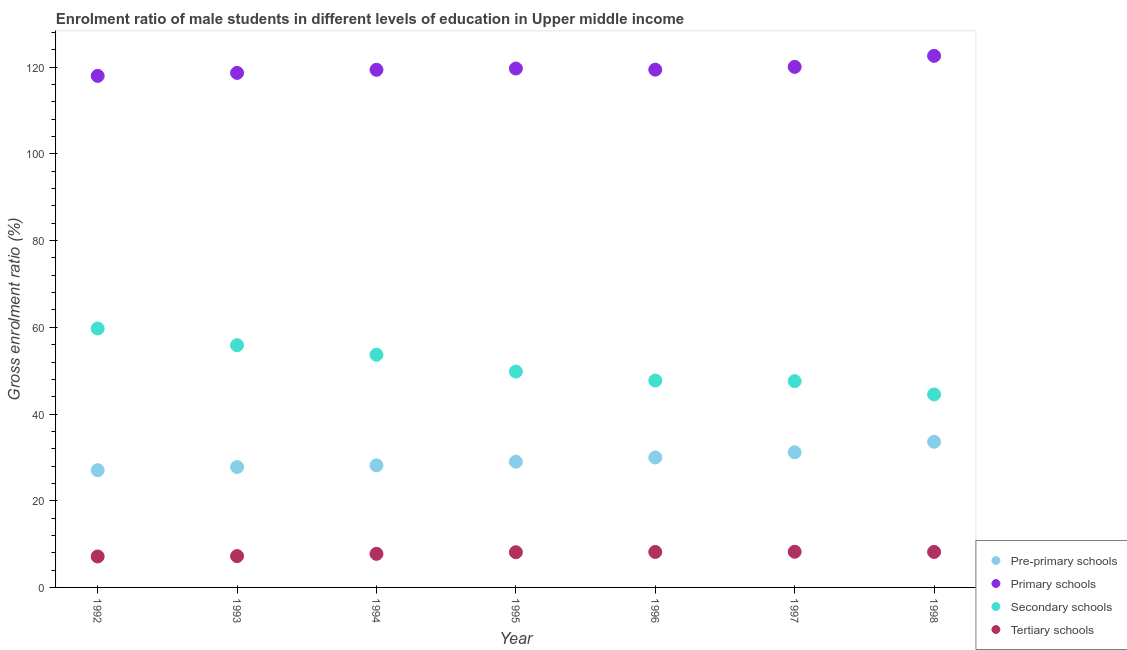How many different coloured dotlines are there?
Provide a short and direct response. 4. Is the number of dotlines equal to the number of legend labels?
Your answer should be compact. Yes. What is the gross enrolment ratio(female) in tertiary schools in 1994?
Provide a succinct answer. 7.74. Across all years, what is the maximum gross enrolment ratio(female) in pre-primary schools?
Provide a succinct answer. 33.59. Across all years, what is the minimum gross enrolment ratio(female) in secondary schools?
Provide a short and direct response. 44.52. In which year was the gross enrolment ratio(female) in primary schools maximum?
Your response must be concise. 1998. In which year was the gross enrolment ratio(female) in secondary schools minimum?
Make the answer very short. 1998. What is the total gross enrolment ratio(female) in secondary schools in the graph?
Give a very brief answer. 358.91. What is the difference between the gross enrolment ratio(female) in pre-primary schools in 1993 and that in 1996?
Make the answer very short. -2.2. What is the difference between the gross enrolment ratio(female) in secondary schools in 1996 and the gross enrolment ratio(female) in primary schools in 1995?
Provide a short and direct response. -71.98. What is the average gross enrolment ratio(female) in pre-primary schools per year?
Offer a terse response. 29.53. In the year 1996, what is the difference between the gross enrolment ratio(female) in pre-primary schools and gross enrolment ratio(female) in primary schools?
Keep it short and to the point. -89.47. What is the ratio of the gross enrolment ratio(female) in pre-primary schools in 1994 to that in 1997?
Ensure brevity in your answer.  0.9. Is the difference between the gross enrolment ratio(female) in primary schools in 1992 and 1994 greater than the difference between the gross enrolment ratio(female) in pre-primary schools in 1992 and 1994?
Your answer should be very brief. No. What is the difference between the highest and the second highest gross enrolment ratio(female) in primary schools?
Provide a short and direct response. 2.54. What is the difference between the highest and the lowest gross enrolment ratio(female) in primary schools?
Provide a succinct answer. 4.62. Is the sum of the gross enrolment ratio(female) in tertiary schools in 1992 and 1994 greater than the maximum gross enrolment ratio(female) in primary schools across all years?
Ensure brevity in your answer.  No. Is it the case that in every year, the sum of the gross enrolment ratio(female) in primary schools and gross enrolment ratio(female) in tertiary schools is greater than the sum of gross enrolment ratio(female) in pre-primary schools and gross enrolment ratio(female) in secondary schools?
Offer a very short reply. Yes. Is the gross enrolment ratio(female) in tertiary schools strictly less than the gross enrolment ratio(female) in secondary schools over the years?
Your answer should be compact. Yes. How many dotlines are there?
Offer a terse response. 4. How many years are there in the graph?
Your response must be concise. 7. What is the difference between two consecutive major ticks on the Y-axis?
Provide a succinct answer. 20. Are the values on the major ticks of Y-axis written in scientific E-notation?
Provide a succinct answer. No. What is the title of the graph?
Give a very brief answer. Enrolment ratio of male students in different levels of education in Upper middle income. Does "Management rating" appear as one of the legend labels in the graph?
Provide a succinct answer. No. What is the Gross enrolment ratio (%) of Pre-primary schools in 1992?
Provide a short and direct response. 27.05. What is the Gross enrolment ratio (%) of Primary schools in 1992?
Ensure brevity in your answer.  118.01. What is the Gross enrolment ratio (%) in Secondary schools in 1992?
Offer a very short reply. 59.73. What is the Gross enrolment ratio (%) in Tertiary schools in 1992?
Give a very brief answer. 7.14. What is the Gross enrolment ratio (%) of Pre-primary schools in 1993?
Your answer should be very brief. 27.77. What is the Gross enrolment ratio (%) of Primary schools in 1993?
Your response must be concise. 118.7. What is the Gross enrolment ratio (%) in Secondary schools in 1993?
Provide a short and direct response. 55.88. What is the Gross enrolment ratio (%) in Tertiary schools in 1993?
Provide a succinct answer. 7.23. What is the Gross enrolment ratio (%) in Pre-primary schools in 1994?
Make the answer very short. 28.16. What is the Gross enrolment ratio (%) of Primary schools in 1994?
Ensure brevity in your answer.  119.41. What is the Gross enrolment ratio (%) in Secondary schools in 1994?
Ensure brevity in your answer.  53.68. What is the Gross enrolment ratio (%) in Tertiary schools in 1994?
Your answer should be very brief. 7.74. What is the Gross enrolment ratio (%) in Pre-primary schools in 1995?
Ensure brevity in your answer.  29. What is the Gross enrolment ratio (%) of Primary schools in 1995?
Keep it short and to the point. 119.7. What is the Gross enrolment ratio (%) in Secondary schools in 1995?
Your answer should be compact. 49.79. What is the Gross enrolment ratio (%) in Tertiary schools in 1995?
Keep it short and to the point. 8.12. What is the Gross enrolment ratio (%) of Pre-primary schools in 1996?
Your response must be concise. 29.97. What is the Gross enrolment ratio (%) in Primary schools in 1996?
Provide a short and direct response. 119.44. What is the Gross enrolment ratio (%) in Secondary schools in 1996?
Your answer should be very brief. 47.72. What is the Gross enrolment ratio (%) in Tertiary schools in 1996?
Make the answer very short. 8.19. What is the Gross enrolment ratio (%) of Pre-primary schools in 1997?
Provide a succinct answer. 31.18. What is the Gross enrolment ratio (%) in Primary schools in 1997?
Make the answer very short. 120.08. What is the Gross enrolment ratio (%) in Secondary schools in 1997?
Offer a terse response. 47.59. What is the Gross enrolment ratio (%) in Tertiary schools in 1997?
Ensure brevity in your answer.  8.23. What is the Gross enrolment ratio (%) of Pre-primary schools in 1998?
Provide a succinct answer. 33.59. What is the Gross enrolment ratio (%) in Primary schools in 1998?
Your answer should be very brief. 122.63. What is the Gross enrolment ratio (%) of Secondary schools in 1998?
Your answer should be compact. 44.52. What is the Gross enrolment ratio (%) of Tertiary schools in 1998?
Your response must be concise. 8.19. Across all years, what is the maximum Gross enrolment ratio (%) of Pre-primary schools?
Provide a short and direct response. 33.59. Across all years, what is the maximum Gross enrolment ratio (%) in Primary schools?
Make the answer very short. 122.63. Across all years, what is the maximum Gross enrolment ratio (%) in Secondary schools?
Your answer should be compact. 59.73. Across all years, what is the maximum Gross enrolment ratio (%) of Tertiary schools?
Provide a short and direct response. 8.23. Across all years, what is the minimum Gross enrolment ratio (%) of Pre-primary schools?
Make the answer very short. 27.05. Across all years, what is the minimum Gross enrolment ratio (%) in Primary schools?
Your response must be concise. 118.01. Across all years, what is the minimum Gross enrolment ratio (%) of Secondary schools?
Give a very brief answer. 44.52. Across all years, what is the minimum Gross enrolment ratio (%) in Tertiary schools?
Your response must be concise. 7.14. What is the total Gross enrolment ratio (%) in Pre-primary schools in the graph?
Keep it short and to the point. 206.73. What is the total Gross enrolment ratio (%) of Primary schools in the graph?
Your answer should be very brief. 837.97. What is the total Gross enrolment ratio (%) in Secondary schools in the graph?
Your response must be concise. 358.91. What is the total Gross enrolment ratio (%) in Tertiary schools in the graph?
Your response must be concise. 54.83. What is the difference between the Gross enrolment ratio (%) of Pre-primary schools in 1992 and that in 1993?
Ensure brevity in your answer.  -0.72. What is the difference between the Gross enrolment ratio (%) in Primary schools in 1992 and that in 1993?
Make the answer very short. -0.69. What is the difference between the Gross enrolment ratio (%) of Secondary schools in 1992 and that in 1993?
Your answer should be compact. 3.86. What is the difference between the Gross enrolment ratio (%) of Tertiary schools in 1992 and that in 1993?
Offer a very short reply. -0.09. What is the difference between the Gross enrolment ratio (%) in Pre-primary schools in 1992 and that in 1994?
Provide a succinct answer. -1.11. What is the difference between the Gross enrolment ratio (%) in Primary schools in 1992 and that in 1994?
Keep it short and to the point. -1.4. What is the difference between the Gross enrolment ratio (%) in Secondary schools in 1992 and that in 1994?
Provide a short and direct response. 6.06. What is the difference between the Gross enrolment ratio (%) in Tertiary schools in 1992 and that in 1994?
Provide a succinct answer. -0.6. What is the difference between the Gross enrolment ratio (%) of Pre-primary schools in 1992 and that in 1995?
Your answer should be compact. -1.95. What is the difference between the Gross enrolment ratio (%) of Primary schools in 1992 and that in 1995?
Make the answer very short. -1.7. What is the difference between the Gross enrolment ratio (%) in Secondary schools in 1992 and that in 1995?
Give a very brief answer. 9.94. What is the difference between the Gross enrolment ratio (%) in Tertiary schools in 1992 and that in 1995?
Provide a short and direct response. -0.98. What is the difference between the Gross enrolment ratio (%) in Pre-primary schools in 1992 and that in 1996?
Offer a terse response. -2.92. What is the difference between the Gross enrolment ratio (%) in Primary schools in 1992 and that in 1996?
Keep it short and to the point. -1.44. What is the difference between the Gross enrolment ratio (%) in Secondary schools in 1992 and that in 1996?
Ensure brevity in your answer.  12.01. What is the difference between the Gross enrolment ratio (%) in Tertiary schools in 1992 and that in 1996?
Your response must be concise. -1.04. What is the difference between the Gross enrolment ratio (%) of Pre-primary schools in 1992 and that in 1997?
Your response must be concise. -4.13. What is the difference between the Gross enrolment ratio (%) of Primary schools in 1992 and that in 1997?
Keep it short and to the point. -2.08. What is the difference between the Gross enrolment ratio (%) of Secondary schools in 1992 and that in 1997?
Ensure brevity in your answer.  12.15. What is the difference between the Gross enrolment ratio (%) in Tertiary schools in 1992 and that in 1997?
Make the answer very short. -1.09. What is the difference between the Gross enrolment ratio (%) of Pre-primary schools in 1992 and that in 1998?
Your response must be concise. -6.54. What is the difference between the Gross enrolment ratio (%) of Primary schools in 1992 and that in 1998?
Ensure brevity in your answer.  -4.62. What is the difference between the Gross enrolment ratio (%) of Secondary schools in 1992 and that in 1998?
Offer a very short reply. 15.21. What is the difference between the Gross enrolment ratio (%) in Tertiary schools in 1992 and that in 1998?
Your answer should be very brief. -1.05. What is the difference between the Gross enrolment ratio (%) of Pre-primary schools in 1993 and that in 1994?
Your answer should be very brief. -0.39. What is the difference between the Gross enrolment ratio (%) in Primary schools in 1993 and that in 1994?
Keep it short and to the point. -0.71. What is the difference between the Gross enrolment ratio (%) in Secondary schools in 1993 and that in 1994?
Provide a short and direct response. 2.2. What is the difference between the Gross enrolment ratio (%) in Tertiary schools in 1993 and that in 1994?
Provide a short and direct response. -0.52. What is the difference between the Gross enrolment ratio (%) in Pre-primary schools in 1993 and that in 1995?
Offer a very short reply. -1.23. What is the difference between the Gross enrolment ratio (%) in Primary schools in 1993 and that in 1995?
Provide a short and direct response. -1.01. What is the difference between the Gross enrolment ratio (%) of Secondary schools in 1993 and that in 1995?
Offer a very short reply. 6.08. What is the difference between the Gross enrolment ratio (%) of Tertiary schools in 1993 and that in 1995?
Keep it short and to the point. -0.89. What is the difference between the Gross enrolment ratio (%) of Pre-primary schools in 1993 and that in 1996?
Offer a very short reply. -2.2. What is the difference between the Gross enrolment ratio (%) in Primary schools in 1993 and that in 1996?
Make the answer very short. -0.75. What is the difference between the Gross enrolment ratio (%) of Secondary schools in 1993 and that in 1996?
Offer a very short reply. 8.16. What is the difference between the Gross enrolment ratio (%) of Tertiary schools in 1993 and that in 1996?
Offer a terse response. -0.96. What is the difference between the Gross enrolment ratio (%) of Pre-primary schools in 1993 and that in 1997?
Give a very brief answer. -3.41. What is the difference between the Gross enrolment ratio (%) of Primary schools in 1993 and that in 1997?
Your answer should be very brief. -1.39. What is the difference between the Gross enrolment ratio (%) in Secondary schools in 1993 and that in 1997?
Give a very brief answer. 8.29. What is the difference between the Gross enrolment ratio (%) in Tertiary schools in 1993 and that in 1997?
Your answer should be very brief. -1. What is the difference between the Gross enrolment ratio (%) of Pre-primary schools in 1993 and that in 1998?
Provide a succinct answer. -5.82. What is the difference between the Gross enrolment ratio (%) of Primary schools in 1993 and that in 1998?
Provide a short and direct response. -3.93. What is the difference between the Gross enrolment ratio (%) of Secondary schools in 1993 and that in 1998?
Your answer should be very brief. 11.36. What is the difference between the Gross enrolment ratio (%) of Tertiary schools in 1993 and that in 1998?
Your response must be concise. -0.96. What is the difference between the Gross enrolment ratio (%) in Pre-primary schools in 1994 and that in 1995?
Give a very brief answer. -0.83. What is the difference between the Gross enrolment ratio (%) of Primary schools in 1994 and that in 1995?
Give a very brief answer. -0.29. What is the difference between the Gross enrolment ratio (%) in Secondary schools in 1994 and that in 1995?
Your response must be concise. 3.88. What is the difference between the Gross enrolment ratio (%) of Tertiary schools in 1994 and that in 1995?
Offer a very short reply. -0.37. What is the difference between the Gross enrolment ratio (%) of Pre-primary schools in 1994 and that in 1996?
Your answer should be compact. -1.81. What is the difference between the Gross enrolment ratio (%) in Primary schools in 1994 and that in 1996?
Offer a very short reply. -0.03. What is the difference between the Gross enrolment ratio (%) in Secondary schools in 1994 and that in 1996?
Ensure brevity in your answer.  5.95. What is the difference between the Gross enrolment ratio (%) of Tertiary schools in 1994 and that in 1996?
Your answer should be very brief. -0.44. What is the difference between the Gross enrolment ratio (%) in Pre-primary schools in 1994 and that in 1997?
Offer a very short reply. -3.02. What is the difference between the Gross enrolment ratio (%) of Primary schools in 1994 and that in 1997?
Your response must be concise. -0.68. What is the difference between the Gross enrolment ratio (%) in Secondary schools in 1994 and that in 1997?
Ensure brevity in your answer.  6.09. What is the difference between the Gross enrolment ratio (%) of Tertiary schools in 1994 and that in 1997?
Make the answer very short. -0.48. What is the difference between the Gross enrolment ratio (%) in Pre-primary schools in 1994 and that in 1998?
Offer a very short reply. -5.43. What is the difference between the Gross enrolment ratio (%) in Primary schools in 1994 and that in 1998?
Your answer should be very brief. -3.22. What is the difference between the Gross enrolment ratio (%) of Secondary schools in 1994 and that in 1998?
Offer a terse response. 9.15. What is the difference between the Gross enrolment ratio (%) in Tertiary schools in 1994 and that in 1998?
Keep it short and to the point. -0.45. What is the difference between the Gross enrolment ratio (%) of Pre-primary schools in 1995 and that in 1996?
Provide a succinct answer. -0.98. What is the difference between the Gross enrolment ratio (%) of Primary schools in 1995 and that in 1996?
Keep it short and to the point. 0.26. What is the difference between the Gross enrolment ratio (%) of Secondary schools in 1995 and that in 1996?
Ensure brevity in your answer.  2.07. What is the difference between the Gross enrolment ratio (%) of Tertiary schools in 1995 and that in 1996?
Your response must be concise. -0.07. What is the difference between the Gross enrolment ratio (%) in Pre-primary schools in 1995 and that in 1997?
Provide a succinct answer. -2.18. What is the difference between the Gross enrolment ratio (%) in Primary schools in 1995 and that in 1997?
Give a very brief answer. -0.38. What is the difference between the Gross enrolment ratio (%) in Secondary schools in 1995 and that in 1997?
Make the answer very short. 2.21. What is the difference between the Gross enrolment ratio (%) in Tertiary schools in 1995 and that in 1997?
Your response must be concise. -0.11. What is the difference between the Gross enrolment ratio (%) of Pre-primary schools in 1995 and that in 1998?
Ensure brevity in your answer.  -4.6. What is the difference between the Gross enrolment ratio (%) in Primary schools in 1995 and that in 1998?
Provide a short and direct response. -2.93. What is the difference between the Gross enrolment ratio (%) of Secondary schools in 1995 and that in 1998?
Your answer should be compact. 5.27. What is the difference between the Gross enrolment ratio (%) in Tertiary schools in 1995 and that in 1998?
Your response must be concise. -0.07. What is the difference between the Gross enrolment ratio (%) of Pre-primary schools in 1996 and that in 1997?
Provide a succinct answer. -1.21. What is the difference between the Gross enrolment ratio (%) of Primary schools in 1996 and that in 1997?
Ensure brevity in your answer.  -0.64. What is the difference between the Gross enrolment ratio (%) of Secondary schools in 1996 and that in 1997?
Your answer should be compact. 0.14. What is the difference between the Gross enrolment ratio (%) in Tertiary schools in 1996 and that in 1997?
Keep it short and to the point. -0.04. What is the difference between the Gross enrolment ratio (%) in Pre-primary schools in 1996 and that in 1998?
Your response must be concise. -3.62. What is the difference between the Gross enrolment ratio (%) in Primary schools in 1996 and that in 1998?
Your response must be concise. -3.19. What is the difference between the Gross enrolment ratio (%) in Secondary schools in 1996 and that in 1998?
Offer a terse response. 3.2. What is the difference between the Gross enrolment ratio (%) of Tertiary schools in 1996 and that in 1998?
Provide a succinct answer. -0.01. What is the difference between the Gross enrolment ratio (%) of Pre-primary schools in 1997 and that in 1998?
Provide a short and direct response. -2.41. What is the difference between the Gross enrolment ratio (%) in Primary schools in 1997 and that in 1998?
Offer a terse response. -2.54. What is the difference between the Gross enrolment ratio (%) of Secondary schools in 1997 and that in 1998?
Ensure brevity in your answer.  3.06. What is the difference between the Gross enrolment ratio (%) of Tertiary schools in 1997 and that in 1998?
Give a very brief answer. 0.04. What is the difference between the Gross enrolment ratio (%) of Pre-primary schools in 1992 and the Gross enrolment ratio (%) of Primary schools in 1993?
Provide a short and direct response. -91.65. What is the difference between the Gross enrolment ratio (%) of Pre-primary schools in 1992 and the Gross enrolment ratio (%) of Secondary schools in 1993?
Give a very brief answer. -28.83. What is the difference between the Gross enrolment ratio (%) in Pre-primary schools in 1992 and the Gross enrolment ratio (%) in Tertiary schools in 1993?
Provide a succinct answer. 19.82. What is the difference between the Gross enrolment ratio (%) in Primary schools in 1992 and the Gross enrolment ratio (%) in Secondary schools in 1993?
Offer a terse response. 62.13. What is the difference between the Gross enrolment ratio (%) of Primary schools in 1992 and the Gross enrolment ratio (%) of Tertiary schools in 1993?
Your answer should be very brief. 110.78. What is the difference between the Gross enrolment ratio (%) in Secondary schools in 1992 and the Gross enrolment ratio (%) in Tertiary schools in 1993?
Provide a short and direct response. 52.51. What is the difference between the Gross enrolment ratio (%) in Pre-primary schools in 1992 and the Gross enrolment ratio (%) in Primary schools in 1994?
Offer a terse response. -92.36. What is the difference between the Gross enrolment ratio (%) of Pre-primary schools in 1992 and the Gross enrolment ratio (%) of Secondary schools in 1994?
Provide a short and direct response. -26.62. What is the difference between the Gross enrolment ratio (%) of Pre-primary schools in 1992 and the Gross enrolment ratio (%) of Tertiary schools in 1994?
Give a very brief answer. 19.31. What is the difference between the Gross enrolment ratio (%) of Primary schools in 1992 and the Gross enrolment ratio (%) of Secondary schools in 1994?
Your answer should be compact. 64.33. What is the difference between the Gross enrolment ratio (%) in Primary schools in 1992 and the Gross enrolment ratio (%) in Tertiary schools in 1994?
Your answer should be very brief. 110.26. What is the difference between the Gross enrolment ratio (%) in Secondary schools in 1992 and the Gross enrolment ratio (%) in Tertiary schools in 1994?
Your answer should be compact. 51.99. What is the difference between the Gross enrolment ratio (%) of Pre-primary schools in 1992 and the Gross enrolment ratio (%) of Primary schools in 1995?
Provide a succinct answer. -92.65. What is the difference between the Gross enrolment ratio (%) of Pre-primary schools in 1992 and the Gross enrolment ratio (%) of Secondary schools in 1995?
Offer a very short reply. -22.74. What is the difference between the Gross enrolment ratio (%) of Pre-primary schools in 1992 and the Gross enrolment ratio (%) of Tertiary schools in 1995?
Give a very brief answer. 18.93. What is the difference between the Gross enrolment ratio (%) of Primary schools in 1992 and the Gross enrolment ratio (%) of Secondary schools in 1995?
Offer a very short reply. 68.21. What is the difference between the Gross enrolment ratio (%) in Primary schools in 1992 and the Gross enrolment ratio (%) in Tertiary schools in 1995?
Your response must be concise. 109.89. What is the difference between the Gross enrolment ratio (%) of Secondary schools in 1992 and the Gross enrolment ratio (%) of Tertiary schools in 1995?
Your answer should be compact. 51.62. What is the difference between the Gross enrolment ratio (%) of Pre-primary schools in 1992 and the Gross enrolment ratio (%) of Primary schools in 1996?
Offer a very short reply. -92.39. What is the difference between the Gross enrolment ratio (%) in Pre-primary schools in 1992 and the Gross enrolment ratio (%) in Secondary schools in 1996?
Make the answer very short. -20.67. What is the difference between the Gross enrolment ratio (%) of Pre-primary schools in 1992 and the Gross enrolment ratio (%) of Tertiary schools in 1996?
Ensure brevity in your answer.  18.87. What is the difference between the Gross enrolment ratio (%) of Primary schools in 1992 and the Gross enrolment ratio (%) of Secondary schools in 1996?
Offer a terse response. 70.28. What is the difference between the Gross enrolment ratio (%) in Primary schools in 1992 and the Gross enrolment ratio (%) in Tertiary schools in 1996?
Your answer should be very brief. 109.82. What is the difference between the Gross enrolment ratio (%) in Secondary schools in 1992 and the Gross enrolment ratio (%) in Tertiary schools in 1996?
Provide a succinct answer. 51.55. What is the difference between the Gross enrolment ratio (%) in Pre-primary schools in 1992 and the Gross enrolment ratio (%) in Primary schools in 1997?
Ensure brevity in your answer.  -93.03. What is the difference between the Gross enrolment ratio (%) in Pre-primary schools in 1992 and the Gross enrolment ratio (%) in Secondary schools in 1997?
Offer a very short reply. -20.54. What is the difference between the Gross enrolment ratio (%) in Pre-primary schools in 1992 and the Gross enrolment ratio (%) in Tertiary schools in 1997?
Provide a succinct answer. 18.82. What is the difference between the Gross enrolment ratio (%) of Primary schools in 1992 and the Gross enrolment ratio (%) of Secondary schools in 1997?
Offer a very short reply. 70.42. What is the difference between the Gross enrolment ratio (%) of Primary schools in 1992 and the Gross enrolment ratio (%) of Tertiary schools in 1997?
Your answer should be compact. 109.78. What is the difference between the Gross enrolment ratio (%) of Secondary schools in 1992 and the Gross enrolment ratio (%) of Tertiary schools in 1997?
Ensure brevity in your answer.  51.51. What is the difference between the Gross enrolment ratio (%) in Pre-primary schools in 1992 and the Gross enrolment ratio (%) in Primary schools in 1998?
Your answer should be very brief. -95.58. What is the difference between the Gross enrolment ratio (%) in Pre-primary schools in 1992 and the Gross enrolment ratio (%) in Secondary schools in 1998?
Provide a short and direct response. -17.47. What is the difference between the Gross enrolment ratio (%) of Pre-primary schools in 1992 and the Gross enrolment ratio (%) of Tertiary schools in 1998?
Your answer should be compact. 18.86. What is the difference between the Gross enrolment ratio (%) of Primary schools in 1992 and the Gross enrolment ratio (%) of Secondary schools in 1998?
Your answer should be compact. 73.48. What is the difference between the Gross enrolment ratio (%) of Primary schools in 1992 and the Gross enrolment ratio (%) of Tertiary schools in 1998?
Make the answer very short. 109.81. What is the difference between the Gross enrolment ratio (%) in Secondary schools in 1992 and the Gross enrolment ratio (%) in Tertiary schools in 1998?
Provide a short and direct response. 51.54. What is the difference between the Gross enrolment ratio (%) of Pre-primary schools in 1993 and the Gross enrolment ratio (%) of Primary schools in 1994?
Offer a very short reply. -91.64. What is the difference between the Gross enrolment ratio (%) of Pre-primary schools in 1993 and the Gross enrolment ratio (%) of Secondary schools in 1994?
Provide a short and direct response. -25.9. What is the difference between the Gross enrolment ratio (%) in Pre-primary schools in 1993 and the Gross enrolment ratio (%) in Tertiary schools in 1994?
Give a very brief answer. 20.03. What is the difference between the Gross enrolment ratio (%) of Primary schools in 1993 and the Gross enrolment ratio (%) of Secondary schools in 1994?
Provide a short and direct response. 65.02. What is the difference between the Gross enrolment ratio (%) of Primary schools in 1993 and the Gross enrolment ratio (%) of Tertiary schools in 1994?
Make the answer very short. 110.95. What is the difference between the Gross enrolment ratio (%) in Secondary schools in 1993 and the Gross enrolment ratio (%) in Tertiary schools in 1994?
Your answer should be very brief. 48.13. What is the difference between the Gross enrolment ratio (%) of Pre-primary schools in 1993 and the Gross enrolment ratio (%) of Primary schools in 1995?
Your answer should be compact. -91.93. What is the difference between the Gross enrolment ratio (%) of Pre-primary schools in 1993 and the Gross enrolment ratio (%) of Secondary schools in 1995?
Provide a succinct answer. -22.02. What is the difference between the Gross enrolment ratio (%) of Pre-primary schools in 1993 and the Gross enrolment ratio (%) of Tertiary schools in 1995?
Your response must be concise. 19.65. What is the difference between the Gross enrolment ratio (%) in Primary schools in 1993 and the Gross enrolment ratio (%) in Secondary schools in 1995?
Ensure brevity in your answer.  68.9. What is the difference between the Gross enrolment ratio (%) of Primary schools in 1993 and the Gross enrolment ratio (%) of Tertiary schools in 1995?
Offer a very short reply. 110.58. What is the difference between the Gross enrolment ratio (%) in Secondary schools in 1993 and the Gross enrolment ratio (%) in Tertiary schools in 1995?
Ensure brevity in your answer.  47.76. What is the difference between the Gross enrolment ratio (%) in Pre-primary schools in 1993 and the Gross enrolment ratio (%) in Primary schools in 1996?
Your answer should be compact. -91.67. What is the difference between the Gross enrolment ratio (%) of Pre-primary schools in 1993 and the Gross enrolment ratio (%) of Secondary schools in 1996?
Your answer should be compact. -19.95. What is the difference between the Gross enrolment ratio (%) of Pre-primary schools in 1993 and the Gross enrolment ratio (%) of Tertiary schools in 1996?
Offer a very short reply. 19.59. What is the difference between the Gross enrolment ratio (%) of Primary schools in 1993 and the Gross enrolment ratio (%) of Secondary schools in 1996?
Ensure brevity in your answer.  70.97. What is the difference between the Gross enrolment ratio (%) in Primary schools in 1993 and the Gross enrolment ratio (%) in Tertiary schools in 1996?
Keep it short and to the point. 110.51. What is the difference between the Gross enrolment ratio (%) in Secondary schools in 1993 and the Gross enrolment ratio (%) in Tertiary schools in 1996?
Provide a short and direct response. 47.69. What is the difference between the Gross enrolment ratio (%) in Pre-primary schools in 1993 and the Gross enrolment ratio (%) in Primary schools in 1997?
Your answer should be compact. -92.31. What is the difference between the Gross enrolment ratio (%) in Pre-primary schools in 1993 and the Gross enrolment ratio (%) in Secondary schools in 1997?
Your answer should be very brief. -19.82. What is the difference between the Gross enrolment ratio (%) in Pre-primary schools in 1993 and the Gross enrolment ratio (%) in Tertiary schools in 1997?
Ensure brevity in your answer.  19.54. What is the difference between the Gross enrolment ratio (%) in Primary schools in 1993 and the Gross enrolment ratio (%) in Secondary schools in 1997?
Make the answer very short. 71.11. What is the difference between the Gross enrolment ratio (%) of Primary schools in 1993 and the Gross enrolment ratio (%) of Tertiary schools in 1997?
Your response must be concise. 110.47. What is the difference between the Gross enrolment ratio (%) in Secondary schools in 1993 and the Gross enrolment ratio (%) in Tertiary schools in 1997?
Offer a very short reply. 47.65. What is the difference between the Gross enrolment ratio (%) of Pre-primary schools in 1993 and the Gross enrolment ratio (%) of Primary schools in 1998?
Give a very brief answer. -94.86. What is the difference between the Gross enrolment ratio (%) of Pre-primary schools in 1993 and the Gross enrolment ratio (%) of Secondary schools in 1998?
Provide a succinct answer. -16.75. What is the difference between the Gross enrolment ratio (%) of Pre-primary schools in 1993 and the Gross enrolment ratio (%) of Tertiary schools in 1998?
Offer a terse response. 19.58. What is the difference between the Gross enrolment ratio (%) in Primary schools in 1993 and the Gross enrolment ratio (%) in Secondary schools in 1998?
Offer a terse response. 74.17. What is the difference between the Gross enrolment ratio (%) in Primary schools in 1993 and the Gross enrolment ratio (%) in Tertiary schools in 1998?
Provide a succinct answer. 110.51. What is the difference between the Gross enrolment ratio (%) of Secondary schools in 1993 and the Gross enrolment ratio (%) of Tertiary schools in 1998?
Offer a terse response. 47.69. What is the difference between the Gross enrolment ratio (%) in Pre-primary schools in 1994 and the Gross enrolment ratio (%) in Primary schools in 1995?
Offer a terse response. -91.54. What is the difference between the Gross enrolment ratio (%) in Pre-primary schools in 1994 and the Gross enrolment ratio (%) in Secondary schools in 1995?
Make the answer very short. -21.63. What is the difference between the Gross enrolment ratio (%) of Pre-primary schools in 1994 and the Gross enrolment ratio (%) of Tertiary schools in 1995?
Your response must be concise. 20.05. What is the difference between the Gross enrolment ratio (%) of Primary schools in 1994 and the Gross enrolment ratio (%) of Secondary schools in 1995?
Give a very brief answer. 69.61. What is the difference between the Gross enrolment ratio (%) of Primary schools in 1994 and the Gross enrolment ratio (%) of Tertiary schools in 1995?
Ensure brevity in your answer.  111.29. What is the difference between the Gross enrolment ratio (%) in Secondary schools in 1994 and the Gross enrolment ratio (%) in Tertiary schools in 1995?
Make the answer very short. 45.56. What is the difference between the Gross enrolment ratio (%) of Pre-primary schools in 1994 and the Gross enrolment ratio (%) of Primary schools in 1996?
Give a very brief answer. -91.28. What is the difference between the Gross enrolment ratio (%) of Pre-primary schools in 1994 and the Gross enrolment ratio (%) of Secondary schools in 1996?
Provide a succinct answer. -19.56. What is the difference between the Gross enrolment ratio (%) of Pre-primary schools in 1994 and the Gross enrolment ratio (%) of Tertiary schools in 1996?
Keep it short and to the point. 19.98. What is the difference between the Gross enrolment ratio (%) in Primary schools in 1994 and the Gross enrolment ratio (%) in Secondary schools in 1996?
Offer a terse response. 71.69. What is the difference between the Gross enrolment ratio (%) in Primary schools in 1994 and the Gross enrolment ratio (%) in Tertiary schools in 1996?
Your answer should be compact. 111.22. What is the difference between the Gross enrolment ratio (%) in Secondary schools in 1994 and the Gross enrolment ratio (%) in Tertiary schools in 1996?
Provide a succinct answer. 45.49. What is the difference between the Gross enrolment ratio (%) in Pre-primary schools in 1994 and the Gross enrolment ratio (%) in Primary schools in 1997?
Provide a short and direct response. -91.92. What is the difference between the Gross enrolment ratio (%) in Pre-primary schools in 1994 and the Gross enrolment ratio (%) in Secondary schools in 1997?
Ensure brevity in your answer.  -19.42. What is the difference between the Gross enrolment ratio (%) of Pre-primary schools in 1994 and the Gross enrolment ratio (%) of Tertiary schools in 1997?
Offer a terse response. 19.94. What is the difference between the Gross enrolment ratio (%) of Primary schools in 1994 and the Gross enrolment ratio (%) of Secondary schools in 1997?
Ensure brevity in your answer.  71.82. What is the difference between the Gross enrolment ratio (%) in Primary schools in 1994 and the Gross enrolment ratio (%) in Tertiary schools in 1997?
Your response must be concise. 111.18. What is the difference between the Gross enrolment ratio (%) in Secondary schools in 1994 and the Gross enrolment ratio (%) in Tertiary schools in 1997?
Make the answer very short. 45.45. What is the difference between the Gross enrolment ratio (%) in Pre-primary schools in 1994 and the Gross enrolment ratio (%) in Primary schools in 1998?
Keep it short and to the point. -94.46. What is the difference between the Gross enrolment ratio (%) of Pre-primary schools in 1994 and the Gross enrolment ratio (%) of Secondary schools in 1998?
Your answer should be compact. -16.36. What is the difference between the Gross enrolment ratio (%) in Pre-primary schools in 1994 and the Gross enrolment ratio (%) in Tertiary schools in 1998?
Provide a succinct answer. 19.97. What is the difference between the Gross enrolment ratio (%) of Primary schools in 1994 and the Gross enrolment ratio (%) of Secondary schools in 1998?
Your answer should be compact. 74.89. What is the difference between the Gross enrolment ratio (%) in Primary schools in 1994 and the Gross enrolment ratio (%) in Tertiary schools in 1998?
Provide a succinct answer. 111.22. What is the difference between the Gross enrolment ratio (%) in Secondary schools in 1994 and the Gross enrolment ratio (%) in Tertiary schools in 1998?
Provide a succinct answer. 45.48. What is the difference between the Gross enrolment ratio (%) in Pre-primary schools in 1995 and the Gross enrolment ratio (%) in Primary schools in 1996?
Ensure brevity in your answer.  -90.44. What is the difference between the Gross enrolment ratio (%) of Pre-primary schools in 1995 and the Gross enrolment ratio (%) of Secondary schools in 1996?
Your answer should be compact. -18.72. What is the difference between the Gross enrolment ratio (%) in Pre-primary schools in 1995 and the Gross enrolment ratio (%) in Tertiary schools in 1996?
Your answer should be very brief. 20.81. What is the difference between the Gross enrolment ratio (%) of Primary schools in 1995 and the Gross enrolment ratio (%) of Secondary schools in 1996?
Your answer should be very brief. 71.98. What is the difference between the Gross enrolment ratio (%) of Primary schools in 1995 and the Gross enrolment ratio (%) of Tertiary schools in 1996?
Your response must be concise. 111.52. What is the difference between the Gross enrolment ratio (%) of Secondary schools in 1995 and the Gross enrolment ratio (%) of Tertiary schools in 1996?
Provide a succinct answer. 41.61. What is the difference between the Gross enrolment ratio (%) in Pre-primary schools in 1995 and the Gross enrolment ratio (%) in Primary schools in 1997?
Your response must be concise. -91.09. What is the difference between the Gross enrolment ratio (%) in Pre-primary schools in 1995 and the Gross enrolment ratio (%) in Secondary schools in 1997?
Offer a terse response. -18.59. What is the difference between the Gross enrolment ratio (%) in Pre-primary schools in 1995 and the Gross enrolment ratio (%) in Tertiary schools in 1997?
Your answer should be very brief. 20.77. What is the difference between the Gross enrolment ratio (%) in Primary schools in 1995 and the Gross enrolment ratio (%) in Secondary schools in 1997?
Provide a succinct answer. 72.12. What is the difference between the Gross enrolment ratio (%) in Primary schools in 1995 and the Gross enrolment ratio (%) in Tertiary schools in 1997?
Give a very brief answer. 111.47. What is the difference between the Gross enrolment ratio (%) in Secondary schools in 1995 and the Gross enrolment ratio (%) in Tertiary schools in 1997?
Provide a short and direct response. 41.57. What is the difference between the Gross enrolment ratio (%) in Pre-primary schools in 1995 and the Gross enrolment ratio (%) in Primary schools in 1998?
Provide a short and direct response. -93.63. What is the difference between the Gross enrolment ratio (%) in Pre-primary schools in 1995 and the Gross enrolment ratio (%) in Secondary schools in 1998?
Ensure brevity in your answer.  -15.53. What is the difference between the Gross enrolment ratio (%) in Pre-primary schools in 1995 and the Gross enrolment ratio (%) in Tertiary schools in 1998?
Make the answer very short. 20.81. What is the difference between the Gross enrolment ratio (%) of Primary schools in 1995 and the Gross enrolment ratio (%) of Secondary schools in 1998?
Ensure brevity in your answer.  75.18. What is the difference between the Gross enrolment ratio (%) in Primary schools in 1995 and the Gross enrolment ratio (%) in Tertiary schools in 1998?
Your answer should be very brief. 111.51. What is the difference between the Gross enrolment ratio (%) in Secondary schools in 1995 and the Gross enrolment ratio (%) in Tertiary schools in 1998?
Your response must be concise. 41.6. What is the difference between the Gross enrolment ratio (%) of Pre-primary schools in 1996 and the Gross enrolment ratio (%) of Primary schools in 1997?
Offer a terse response. -90.11. What is the difference between the Gross enrolment ratio (%) of Pre-primary schools in 1996 and the Gross enrolment ratio (%) of Secondary schools in 1997?
Offer a terse response. -17.61. What is the difference between the Gross enrolment ratio (%) in Pre-primary schools in 1996 and the Gross enrolment ratio (%) in Tertiary schools in 1997?
Your response must be concise. 21.75. What is the difference between the Gross enrolment ratio (%) of Primary schools in 1996 and the Gross enrolment ratio (%) of Secondary schools in 1997?
Your answer should be very brief. 71.86. What is the difference between the Gross enrolment ratio (%) in Primary schools in 1996 and the Gross enrolment ratio (%) in Tertiary schools in 1997?
Ensure brevity in your answer.  111.21. What is the difference between the Gross enrolment ratio (%) of Secondary schools in 1996 and the Gross enrolment ratio (%) of Tertiary schools in 1997?
Your response must be concise. 39.49. What is the difference between the Gross enrolment ratio (%) of Pre-primary schools in 1996 and the Gross enrolment ratio (%) of Primary schools in 1998?
Your response must be concise. -92.65. What is the difference between the Gross enrolment ratio (%) in Pre-primary schools in 1996 and the Gross enrolment ratio (%) in Secondary schools in 1998?
Ensure brevity in your answer.  -14.55. What is the difference between the Gross enrolment ratio (%) of Pre-primary schools in 1996 and the Gross enrolment ratio (%) of Tertiary schools in 1998?
Your response must be concise. 21.78. What is the difference between the Gross enrolment ratio (%) in Primary schools in 1996 and the Gross enrolment ratio (%) in Secondary schools in 1998?
Offer a terse response. 74.92. What is the difference between the Gross enrolment ratio (%) of Primary schools in 1996 and the Gross enrolment ratio (%) of Tertiary schools in 1998?
Provide a succinct answer. 111.25. What is the difference between the Gross enrolment ratio (%) of Secondary schools in 1996 and the Gross enrolment ratio (%) of Tertiary schools in 1998?
Provide a short and direct response. 39.53. What is the difference between the Gross enrolment ratio (%) in Pre-primary schools in 1997 and the Gross enrolment ratio (%) in Primary schools in 1998?
Provide a succinct answer. -91.45. What is the difference between the Gross enrolment ratio (%) of Pre-primary schools in 1997 and the Gross enrolment ratio (%) of Secondary schools in 1998?
Provide a succinct answer. -13.34. What is the difference between the Gross enrolment ratio (%) in Pre-primary schools in 1997 and the Gross enrolment ratio (%) in Tertiary schools in 1998?
Make the answer very short. 22.99. What is the difference between the Gross enrolment ratio (%) of Primary schools in 1997 and the Gross enrolment ratio (%) of Secondary schools in 1998?
Provide a short and direct response. 75.56. What is the difference between the Gross enrolment ratio (%) in Primary schools in 1997 and the Gross enrolment ratio (%) in Tertiary schools in 1998?
Keep it short and to the point. 111.89. What is the difference between the Gross enrolment ratio (%) in Secondary schools in 1997 and the Gross enrolment ratio (%) in Tertiary schools in 1998?
Offer a very short reply. 39.4. What is the average Gross enrolment ratio (%) in Pre-primary schools per year?
Provide a short and direct response. 29.53. What is the average Gross enrolment ratio (%) in Primary schools per year?
Provide a short and direct response. 119.71. What is the average Gross enrolment ratio (%) in Secondary schools per year?
Provide a short and direct response. 51.27. What is the average Gross enrolment ratio (%) in Tertiary schools per year?
Your answer should be compact. 7.83. In the year 1992, what is the difference between the Gross enrolment ratio (%) of Pre-primary schools and Gross enrolment ratio (%) of Primary schools?
Your answer should be very brief. -90.96. In the year 1992, what is the difference between the Gross enrolment ratio (%) in Pre-primary schools and Gross enrolment ratio (%) in Secondary schools?
Make the answer very short. -32.68. In the year 1992, what is the difference between the Gross enrolment ratio (%) of Pre-primary schools and Gross enrolment ratio (%) of Tertiary schools?
Keep it short and to the point. 19.91. In the year 1992, what is the difference between the Gross enrolment ratio (%) of Primary schools and Gross enrolment ratio (%) of Secondary schools?
Offer a very short reply. 58.27. In the year 1992, what is the difference between the Gross enrolment ratio (%) in Primary schools and Gross enrolment ratio (%) in Tertiary schools?
Ensure brevity in your answer.  110.86. In the year 1992, what is the difference between the Gross enrolment ratio (%) of Secondary schools and Gross enrolment ratio (%) of Tertiary schools?
Your response must be concise. 52.59. In the year 1993, what is the difference between the Gross enrolment ratio (%) of Pre-primary schools and Gross enrolment ratio (%) of Primary schools?
Provide a short and direct response. -90.93. In the year 1993, what is the difference between the Gross enrolment ratio (%) in Pre-primary schools and Gross enrolment ratio (%) in Secondary schools?
Provide a short and direct response. -28.11. In the year 1993, what is the difference between the Gross enrolment ratio (%) in Pre-primary schools and Gross enrolment ratio (%) in Tertiary schools?
Your response must be concise. 20.54. In the year 1993, what is the difference between the Gross enrolment ratio (%) in Primary schools and Gross enrolment ratio (%) in Secondary schools?
Your response must be concise. 62.82. In the year 1993, what is the difference between the Gross enrolment ratio (%) in Primary schools and Gross enrolment ratio (%) in Tertiary schools?
Provide a short and direct response. 111.47. In the year 1993, what is the difference between the Gross enrolment ratio (%) of Secondary schools and Gross enrolment ratio (%) of Tertiary schools?
Your answer should be very brief. 48.65. In the year 1994, what is the difference between the Gross enrolment ratio (%) in Pre-primary schools and Gross enrolment ratio (%) in Primary schools?
Offer a terse response. -91.25. In the year 1994, what is the difference between the Gross enrolment ratio (%) of Pre-primary schools and Gross enrolment ratio (%) of Secondary schools?
Your answer should be compact. -25.51. In the year 1994, what is the difference between the Gross enrolment ratio (%) of Pre-primary schools and Gross enrolment ratio (%) of Tertiary schools?
Your response must be concise. 20.42. In the year 1994, what is the difference between the Gross enrolment ratio (%) in Primary schools and Gross enrolment ratio (%) in Secondary schools?
Ensure brevity in your answer.  65.73. In the year 1994, what is the difference between the Gross enrolment ratio (%) in Primary schools and Gross enrolment ratio (%) in Tertiary schools?
Make the answer very short. 111.66. In the year 1994, what is the difference between the Gross enrolment ratio (%) of Secondary schools and Gross enrolment ratio (%) of Tertiary schools?
Your answer should be very brief. 45.93. In the year 1995, what is the difference between the Gross enrolment ratio (%) in Pre-primary schools and Gross enrolment ratio (%) in Primary schools?
Give a very brief answer. -90.71. In the year 1995, what is the difference between the Gross enrolment ratio (%) in Pre-primary schools and Gross enrolment ratio (%) in Secondary schools?
Give a very brief answer. -20.8. In the year 1995, what is the difference between the Gross enrolment ratio (%) of Pre-primary schools and Gross enrolment ratio (%) of Tertiary schools?
Make the answer very short. 20.88. In the year 1995, what is the difference between the Gross enrolment ratio (%) in Primary schools and Gross enrolment ratio (%) in Secondary schools?
Provide a short and direct response. 69.91. In the year 1995, what is the difference between the Gross enrolment ratio (%) in Primary schools and Gross enrolment ratio (%) in Tertiary schools?
Your answer should be very brief. 111.58. In the year 1995, what is the difference between the Gross enrolment ratio (%) in Secondary schools and Gross enrolment ratio (%) in Tertiary schools?
Your answer should be very brief. 41.68. In the year 1996, what is the difference between the Gross enrolment ratio (%) in Pre-primary schools and Gross enrolment ratio (%) in Primary schools?
Your answer should be very brief. -89.47. In the year 1996, what is the difference between the Gross enrolment ratio (%) of Pre-primary schools and Gross enrolment ratio (%) of Secondary schools?
Give a very brief answer. -17.75. In the year 1996, what is the difference between the Gross enrolment ratio (%) in Pre-primary schools and Gross enrolment ratio (%) in Tertiary schools?
Keep it short and to the point. 21.79. In the year 1996, what is the difference between the Gross enrolment ratio (%) in Primary schools and Gross enrolment ratio (%) in Secondary schools?
Offer a very short reply. 71.72. In the year 1996, what is the difference between the Gross enrolment ratio (%) of Primary schools and Gross enrolment ratio (%) of Tertiary schools?
Provide a short and direct response. 111.26. In the year 1996, what is the difference between the Gross enrolment ratio (%) in Secondary schools and Gross enrolment ratio (%) in Tertiary schools?
Your answer should be very brief. 39.54. In the year 1997, what is the difference between the Gross enrolment ratio (%) of Pre-primary schools and Gross enrolment ratio (%) of Primary schools?
Your response must be concise. -88.9. In the year 1997, what is the difference between the Gross enrolment ratio (%) in Pre-primary schools and Gross enrolment ratio (%) in Secondary schools?
Provide a succinct answer. -16.4. In the year 1997, what is the difference between the Gross enrolment ratio (%) of Pre-primary schools and Gross enrolment ratio (%) of Tertiary schools?
Offer a terse response. 22.95. In the year 1997, what is the difference between the Gross enrolment ratio (%) of Primary schools and Gross enrolment ratio (%) of Secondary schools?
Your response must be concise. 72.5. In the year 1997, what is the difference between the Gross enrolment ratio (%) of Primary schools and Gross enrolment ratio (%) of Tertiary schools?
Your answer should be very brief. 111.86. In the year 1997, what is the difference between the Gross enrolment ratio (%) in Secondary schools and Gross enrolment ratio (%) in Tertiary schools?
Your answer should be compact. 39.36. In the year 1998, what is the difference between the Gross enrolment ratio (%) of Pre-primary schools and Gross enrolment ratio (%) of Primary schools?
Your answer should be very brief. -89.03. In the year 1998, what is the difference between the Gross enrolment ratio (%) in Pre-primary schools and Gross enrolment ratio (%) in Secondary schools?
Provide a succinct answer. -10.93. In the year 1998, what is the difference between the Gross enrolment ratio (%) of Pre-primary schools and Gross enrolment ratio (%) of Tertiary schools?
Offer a very short reply. 25.4. In the year 1998, what is the difference between the Gross enrolment ratio (%) of Primary schools and Gross enrolment ratio (%) of Secondary schools?
Give a very brief answer. 78.11. In the year 1998, what is the difference between the Gross enrolment ratio (%) in Primary schools and Gross enrolment ratio (%) in Tertiary schools?
Keep it short and to the point. 114.44. In the year 1998, what is the difference between the Gross enrolment ratio (%) of Secondary schools and Gross enrolment ratio (%) of Tertiary schools?
Ensure brevity in your answer.  36.33. What is the ratio of the Gross enrolment ratio (%) in Pre-primary schools in 1992 to that in 1993?
Your response must be concise. 0.97. What is the ratio of the Gross enrolment ratio (%) in Primary schools in 1992 to that in 1993?
Ensure brevity in your answer.  0.99. What is the ratio of the Gross enrolment ratio (%) in Secondary schools in 1992 to that in 1993?
Your answer should be very brief. 1.07. What is the ratio of the Gross enrolment ratio (%) of Pre-primary schools in 1992 to that in 1994?
Your response must be concise. 0.96. What is the ratio of the Gross enrolment ratio (%) of Primary schools in 1992 to that in 1994?
Offer a very short reply. 0.99. What is the ratio of the Gross enrolment ratio (%) of Secondary schools in 1992 to that in 1994?
Offer a very short reply. 1.11. What is the ratio of the Gross enrolment ratio (%) in Tertiary schools in 1992 to that in 1994?
Your response must be concise. 0.92. What is the ratio of the Gross enrolment ratio (%) in Pre-primary schools in 1992 to that in 1995?
Provide a succinct answer. 0.93. What is the ratio of the Gross enrolment ratio (%) of Primary schools in 1992 to that in 1995?
Offer a very short reply. 0.99. What is the ratio of the Gross enrolment ratio (%) in Secondary schools in 1992 to that in 1995?
Your answer should be compact. 1.2. What is the ratio of the Gross enrolment ratio (%) of Tertiary schools in 1992 to that in 1995?
Keep it short and to the point. 0.88. What is the ratio of the Gross enrolment ratio (%) in Pre-primary schools in 1992 to that in 1996?
Ensure brevity in your answer.  0.9. What is the ratio of the Gross enrolment ratio (%) of Secondary schools in 1992 to that in 1996?
Offer a very short reply. 1.25. What is the ratio of the Gross enrolment ratio (%) in Tertiary schools in 1992 to that in 1996?
Offer a terse response. 0.87. What is the ratio of the Gross enrolment ratio (%) in Pre-primary schools in 1992 to that in 1997?
Your answer should be compact. 0.87. What is the ratio of the Gross enrolment ratio (%) in Primary schools in 1992 to that in 1997?
Provide a succinct answer. 0.98. What is the ratio of the Gross enrolment ratio (%) in Secondary schools in 1992 to that in 1997?
Your answer should be very brief. 1.26. What is the ratio of the Gross enrolment ratio (%) in Tertiary schools in 1992 to that in 1997?
Keep it short and to the point. 0.87. What is the ratio of the Gross enrolment ratio (%) in Pre-primary schools in 1992 to that in 1998?
Your answer should be compact. 0.81. What is the ratio of the Gross enrolment ratio (%) of Primary schools in 1992 to that in 1998?
Provide a short and direct response. 0.96. What is the ratio of the Gross enrolment ratio (%) of Secondary schools in 1992 to that in 1998?
Make the answer very short. 1.34. What is the ratio of the Gross enrolment ratio (%) in Tertiary schools in 1992 to that in 1998?
Your answer should be very brief. 0.87. What is the ratio of the Gross enrolment ratio (%) of Pre-primary schools in 1993 to that in 1994?
Give a very brief answer. 0.99. What is the ratio of the Gross enrolment ratio (%) in Primary schools in 1993 to that in 1994?
Your answer should be very brief. 0.99. What is the ratio of the Gross enrolment ratio (%) in Secondary schools in 1993 to that in 1994?
Your answer should be compact. 1.04. What is the ratio of the Gross enrolment ratio (%) in Tertiary schools in 1993 to that in 1994?
Ensure brevity in your answer.  0.93. What is the ratio of the Gross enrolment ratio (%) in Pre-primary schools in 1993 to that in 1995?
Offer a very short reply. 0.96. What is the ratio of the Gross enrolment ratio (%) in Primary schools in 1993 to that in 1995?
Keep it short and to the point. 0.99. What is the ratio of the Gross enrolment ratio (%) in Secondary schools in 1993 to that in 1995?
Your answer should be very brief. 1.12. What is the ratio of the Gross enrolment ratio (%) in Tertiary schools in 1993 to that in 1995?
Provide a succinct answer. 0.89. What is the ratio of the Gross enrolment ratio (%) in Pre-primary schools in 1993 to that in 1996?
Provide a succinct answer. 0.93. What is the ratio of the Gross enrolment ratio (%) of Secondary schools in 1993 to that in 1996?
Make the answer very short. 1.17. What is the ratio of the Gross enrolment ratio (%) in Tertiary schools in 1993 to that in 1996?
Give a very brief answer. 0.88. What is the ratio of the Gross enrolment ratio (%) of Pre-primary schools in 1993 to that in 1997?
Your answer should be compact. 0.89. What is the ratio of the Gross enrolment ratio (%) of Primary schools in 1993 to that in 1997?
Make the answer very short. 0.99. What is the ratio of the Gross enrolment ratio (%) in Secondary schools in 1993 to that in 1997?
Offer a terse response. 1.17. What is the ratio of the Gross enrolment ratio (%) in Tertiary schools in 1993 to that in 1997?
Keep it short and to the point. 0.88. What is the ratio of the Gross enrolment ratio (%) of Pre-primary schools in 1993 to that in 1998?
Ensure brevity in your answer.  0.83. What is the ratio of the Gross enrolment ratio (%) in Primary schools in 1993 to that in 1998?
Your answer should be compact. 0.97. What is the ratio of the Gross enrolment ratio (%) of Secondary schools in 1993 to that in 1998?
Offer a terse response. 1.26. What is the ratio of the Gross enrolment ratio (%) in Tertiary schools in 1993 to that in 1998?
Your answer should be compact. 0.88. What is the ratio of the Gross enrolment ratio (%) of Pre-primary schools in 1994 to that in 1995?
Provide a short and direct response. 0.97. What is the ratio of the Gross enrolment ratio (%) in Secondary schools in 1994 to that in 1995?
Give a very brief answer. 1.08. What is the ratio of the Gross enrolment ratio (%) of Tertiary schools in 1994 to that in 1995?
Your answer should be very brief. 0.95. What is the ratio of the Gross enrolment ratio (%) in Pre-primary schools in 1994 to that in 1996?
Keep it short and to the point. 0.94. What is the ratio of the Gross enrolment ratio (%) of Primary schools in 1994 to that in 1996?
Provide a succinct answer. 1. What is the ratio of the Gross enrolment ratio (%) of Secondary schools in 1994 to that in 1996?
Provide a short and direct response. 1.12. What is the ratio of the Gross enrolment ratio (%) of Tertiary schools in 1994 to that in 1996?
Your answer should be compact. 0.95. What is the ratio of the Gross enrolment ratio (%) of Pre-primary schools in 1994 to that in 1997?
Your response must be concise. 0.9. What is the ratio of the Gross enrolment ratio (%) of Secondary schools in 1994 to that in 1997?
Offer a very short reply. 1.13. What is the ratio of the Gross enrolment ratio (%) of Tertiary schools in 1994 to that in 1997?
Keep it short and to the point. 0.94. What is the ratio of the Gross enrolment ratio (%) in Pre-primary schools in 1994 to that in 1998?
Your answer should be compact. 0.84. What is the ratio of the Gross enrolment ratio (%) in Primary schools in 1994 to that in 1998?
Your response must be concise. 0.97. What is the ratio of the Gross enrolment ratio (%) of Secondary schools in 1994 to that in 1998?
Provide a succinct answer. 1.21. What is the ratio of the Gross enrolment ratio (%) of Tertiary schools in 1994 to that in 1998?
Your answer should be very brief. 0.95. What is the ratio of the Gross enrolment ratio (%) in Pre-primary schools in 1995 to that in 1996?
Provide a succinct answer. 0.97. What is the ratio of the Gross enrolment ratio (%) in Primary schools in 1995 to that in 1996?
Offer a terse response. 1. What is the ratio of the Gross enrolment ratio (%) of Secondary schools in 1995 to that in 1996?
Provide a succinct answer. 1.04. What is the ratio of the Gross enrolment ratio (%) of Pre-primary schools in 1995 to that in 1997?
Make the answer very short. 0.93. What is the ratio of the Gross enrolment ratio (%) of Secondary schools in 1995 to that in 1997?
Offer a very short reply. 1.05. What is the ratio of the Gross enrolment ratio (%) in Tertiary schools in 1995 to that in 1997?
Keep it short and to the point. 0.99. What is the ratio of the Gross enrolment ratio (%) in Pre-primary schools in 1995 to that in 1998?
Offer a very short reply. 0.86. What is the ratio of the Gross enrolment ratio (%) in Primary schools in 1995 to that in 1998?
Provide a short and direct response. 0.98. What is the ratio of the Gross enrolment ratio (%) of Secondary schools in 1995 to that in 1998?
Offer a terse response. 1.12. What is the ratio of the Gross enrolment ratio (%) in Tertiary schools in 1995 to that in 1998?
Offer a terse response. 0.99. What is the ratio of the Gross enrolment ratio (%) in Pre-primary schools in 1996 to that in 1997?
Offer a terse response. 0.96. What is the ratio of the Gross enrolment ratio (%) in Primary schools in 1996 to that in 1997?
Your response must be concise. 0.99. What is the ratio of the Gross enrolment ratio (%) in Pre-primary schools in 1996 to that in 1998?
Give a very brief answer. 0.89. What is the ratio of the Gross enrolment ratio (%) of Primary schools in 1996 to that in 1998?
Your response must be concise. 0.97. What is the ratio of the Gross enrolment ratio (%) in Secondary schools in 1996 to that in 1998?
Give a very brief answer. 1.07. What is the ratio of the Gross enrolment ratio (%) of Pre-primary schools in 1997 to that in 1998?
Your answer should be compact. 0.93. What is the ratio of the Gross enrolment ratio (%) in Primary schools in 1997 to that in 1998?
Keep it short and to the point. 0.98. What is the ratio of the Gross enrolment ratio (%) in Secondary schools in 1997 to that in 1998?
Your answer should be compact. 1.07. What is the ratio of the Gross enrolment ratio (%) of Tertiary schools in 1997 to that in 1998?
Your answer should be compact. 1. What is the difference between the highest and the second highest Gross enrolment ratio (%) of Pre-primary schools?
Make the answer very short. 2.41. What is the difference between the highest and the second highest Gross enrolment ratio (%) of Primary schools?
Your response must be concise. 2.54. What is the difference between the highest and the second highest Gross enrolment ratio (%) in Secondary schools?
Keep it short and to the point. 3.86. What is the difference between the highest and the second highest Gross enrolment ratio (%) in Tertiary schools?
Give a very brief answer. 0.04. What is the difference between the highest and the lowest Gross enrolment ratio (%) in Pre-primary schools?
Your answer should be very brief. 6.54. What is the difference between the highest and the lowest Gross enrolment ratio (%) in Primary schools?
Give a very brief answer. 4.62. What is the difference between the highest and the lowest Gross enrolment ratio (%) of Secondary schools?
Keep it short and to the point. 15.21. What is the difference between the highest and the lowest Gross enrolment ratio (%) in Tertiary schools?
Give a very brief answer. 1.09. 